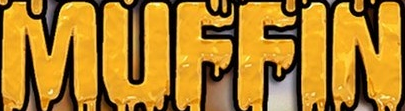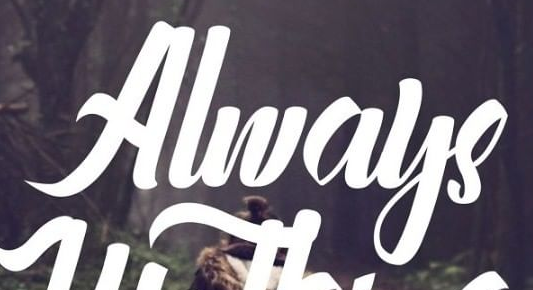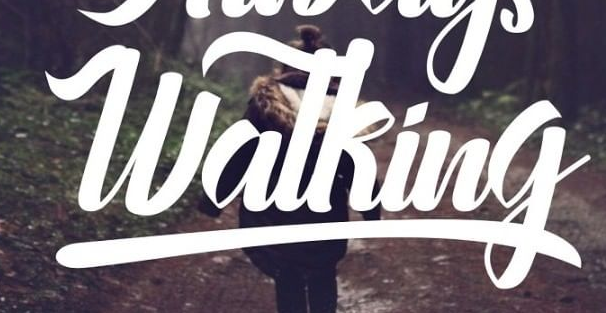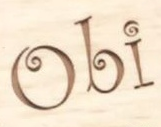Read the text from these images in sequence, separated by a semicolon. MUFFIN; Always; Watking; Obi 